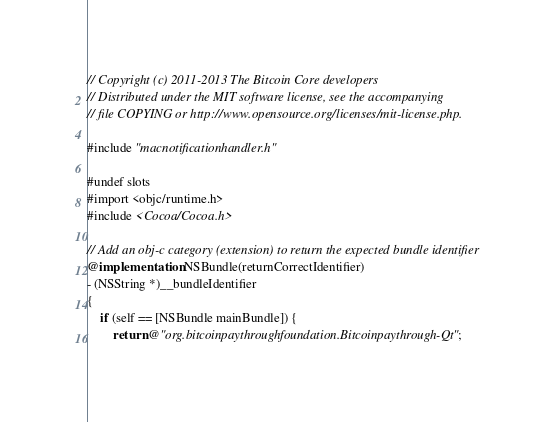<code> <loc_0><loc_0><loc_500><loc_500><_ObjectiveC_>// Copyright (c) 2011-2013 The Bitcoin Core developers
// Distributed under the MIT software license, see the accompanying
// file COPYING or http://www.opensource.org/licenses/mit-license.php.

#include "macnotificationhandler.h"

#undef slots
#import <objc/runtime.h>
#include <Cocoa/Cocoa.h>

// Add an obj-c category (extension) to return the expected bundle identifier
@implementation NSBundle(returnCorrectIdentifier)
- (NSString *)__bundleIdentifier
{
    if (self == [NSBundle mainBundle]) {
        return @"org.bitcoinpaythroughfoundation.Bitcoinpaythrough-Qt";</code> 